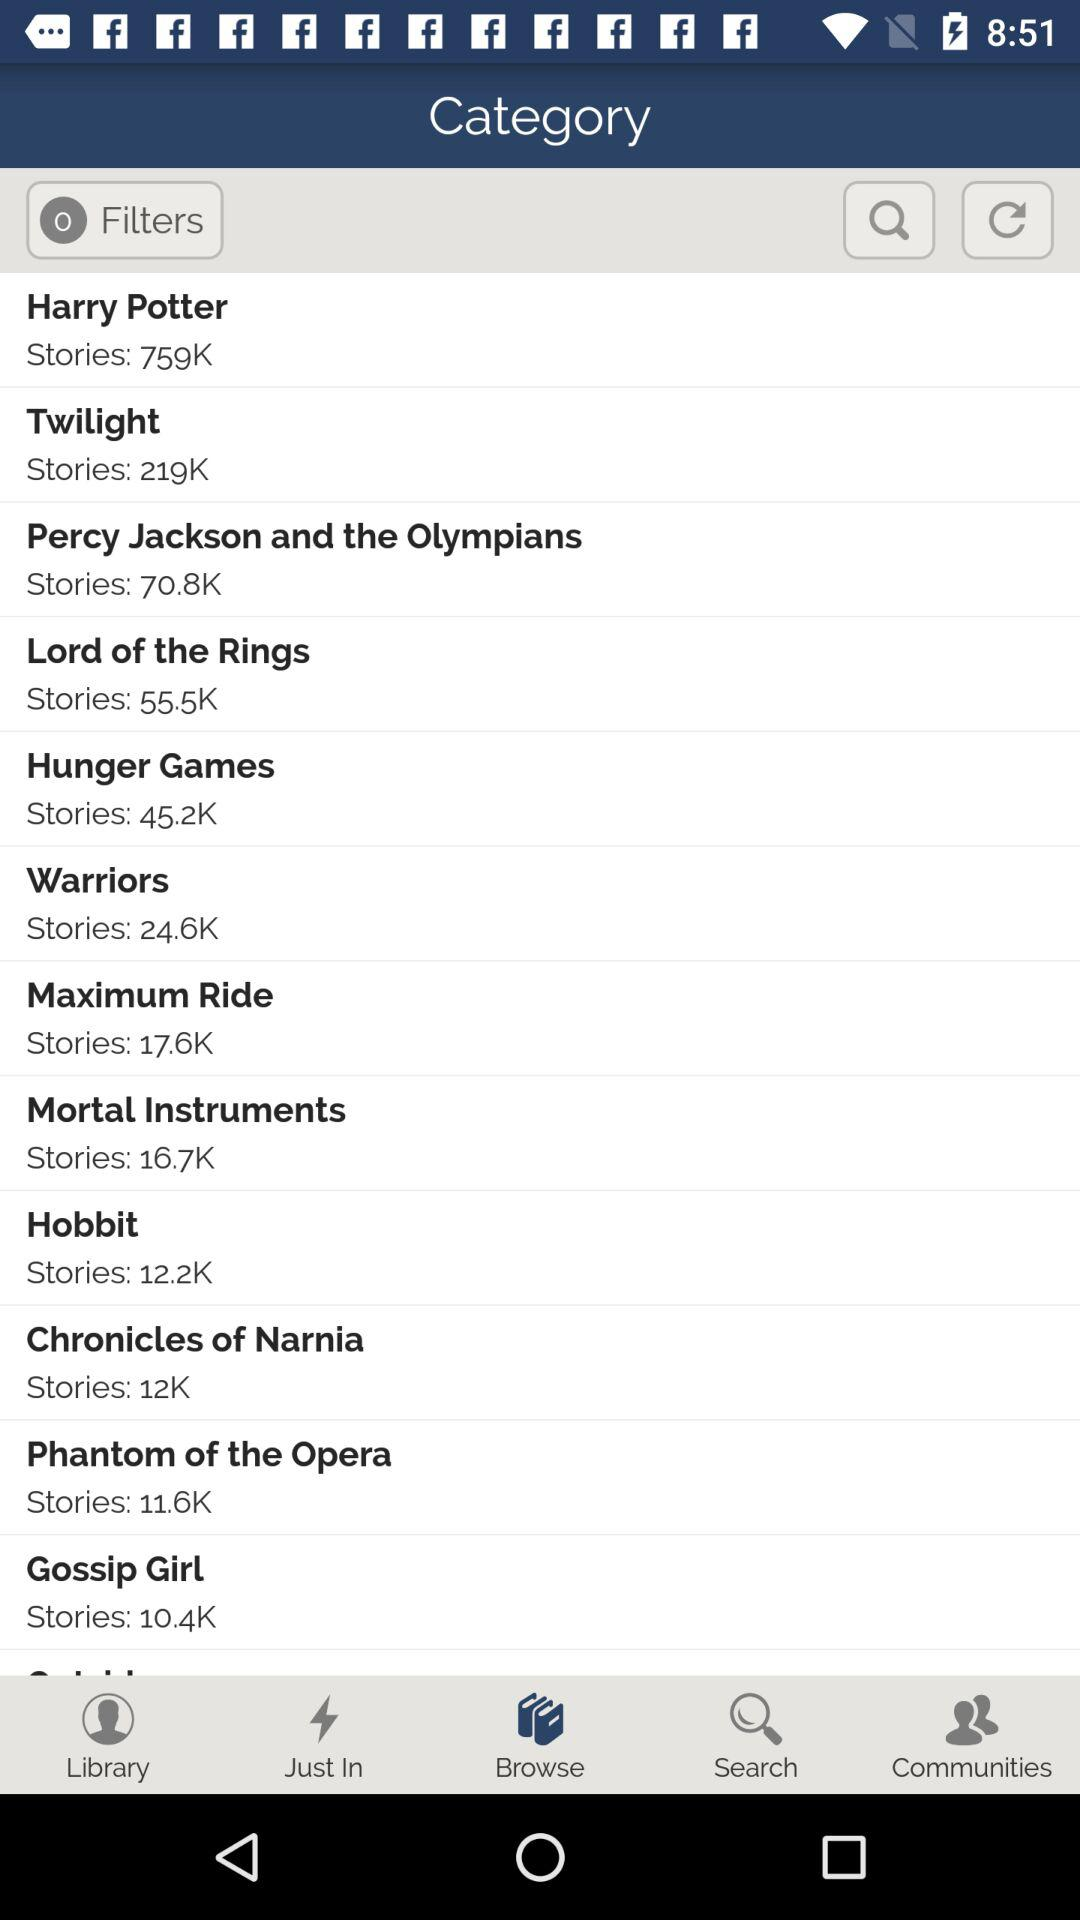Which option has been selected? The selected option is "Browse". 